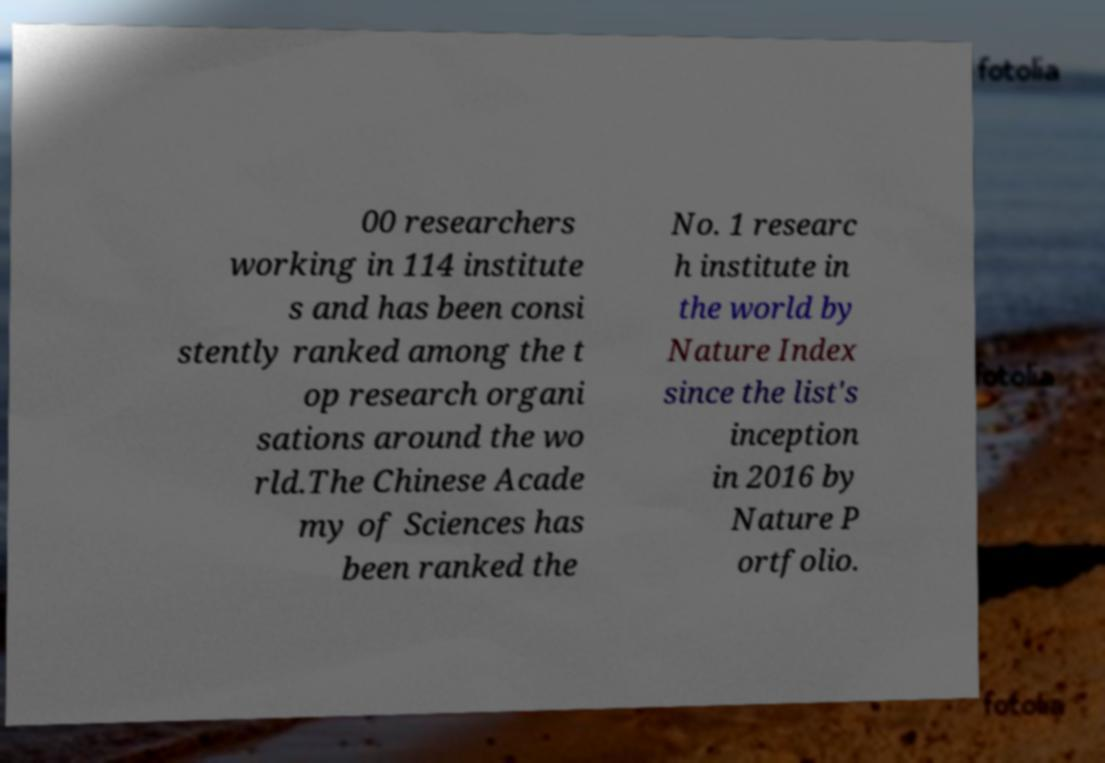I need the written content from this picture converted into text. Can you do that? 00 researchers working in 114 institute s and has been consi stently ranked among the t op research organi sations around the wo rld.The Chinese Acade my of Sciences has been ranked the No. 1 researc h institute in the world by Nature Index since the list's inception in 2016 by Nature P ortfolio. 